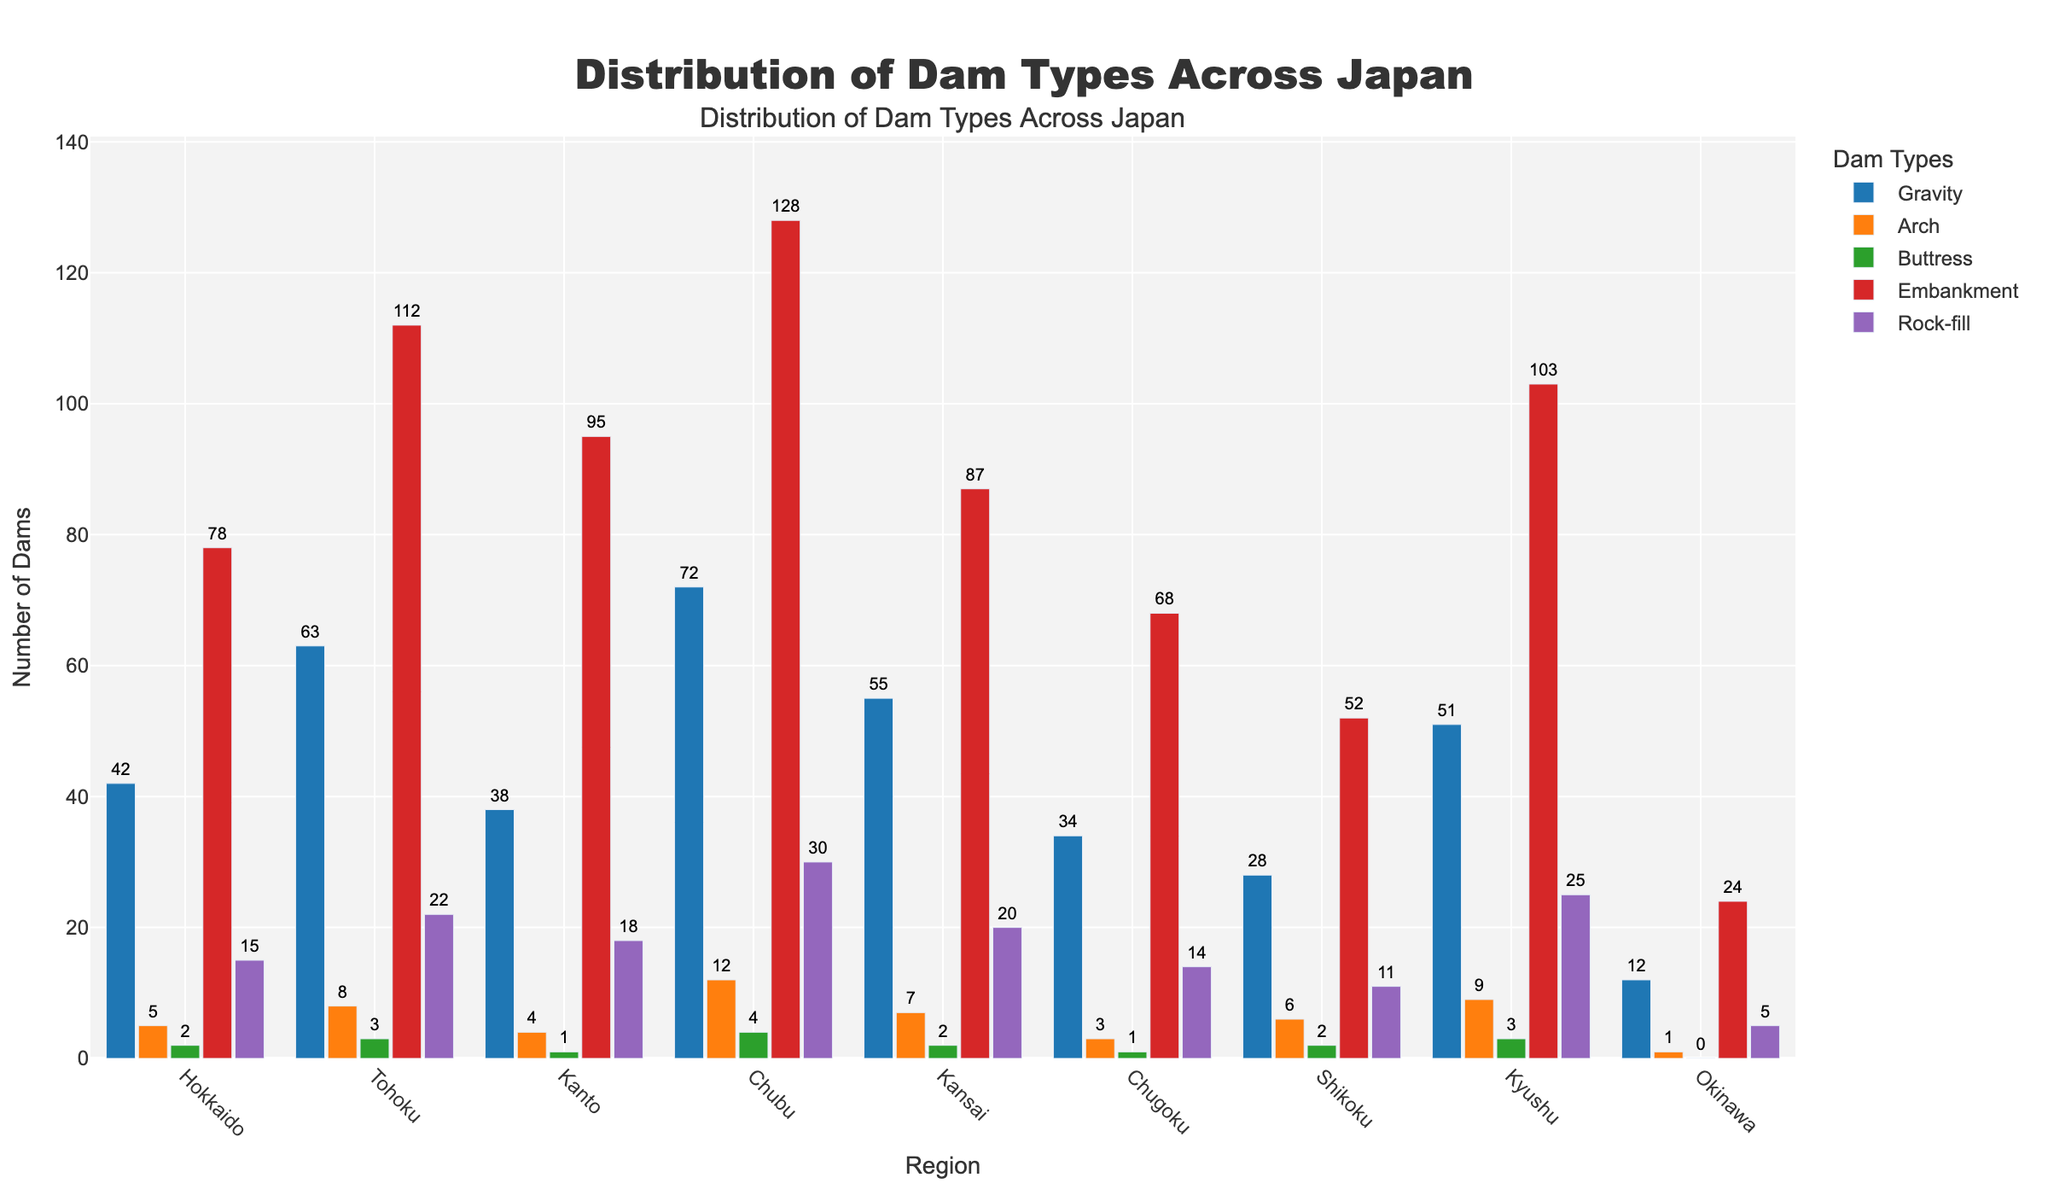Which region has the highest number of gravity dams? Based on the height of the bars representing gravity dams, Chubu has the tallest bar, indicating the highest number.
Answer: Chubu How many total buttress dams are there in Hokkaido and Tohoku combined? Hokkaido has 2 buttress dams, and Tohoku has 3. Adding them together gives 2 + 3 = 5.
Answer: 5 Which region has more embankment dams, Kansai or Okinawa? By comparing the heights of the bars for embankment dams, Kansai has a taller bar than Okinawa.
Answer: Kansai What is the difference in the number of rock-fill dams between Chubu and Kyushu? Chubu has 30 rock-fill dams, while Kyushu has 25. The difference is 30 - 25 = 5.
Answer: 5 Which dam type is consistently the least common across most regions? By scanning across the regions, the bar for Buttress dams is consistently the shortest in most regions.
Answer: Buttress How many more total dams are there in Tohoku compared to Hokkaido when considering all types? Summing the dams in Tohoku gives 63+8+3+112+22=208. Summing dams in Hokkaido gives 42+5+2+78+15=142. The difference is 208 - 142 = 66.
Answer: 66 Which region has the lowest number of arch dams? By comparing the heights of the bars for arch dams across regions, Okinawa has the shortest bar.
Answer: Okinawa What is the average number of gravity dams in the Kanto and Kansai regions? Kanto has 38 gravity dams and Kansai has 55. The average is (38 + 55) / 2 = 46.5.
Answer: 46.5 Is the number of embankment dams in Shikoku greater than the total number of arch dams in Hokkaido and Kyushu combined? Shikoku has 52 embankment dams. Hokkaido has 5 arch dams and Kyushu has 9, totaling 5 + 9 = 14. Since 52 is greater than 14, the answer is yes.
Answer: Yes 